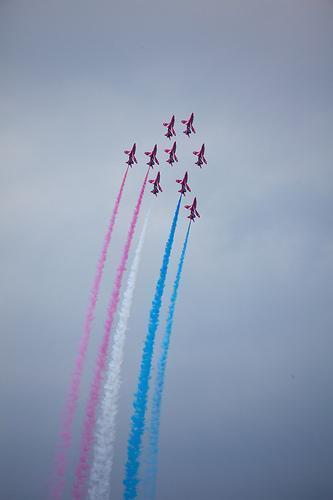How many vehicles are in the sky?
Give a very brief answer. 9. How many white streams are there?
Give a very brief answer. 1. 